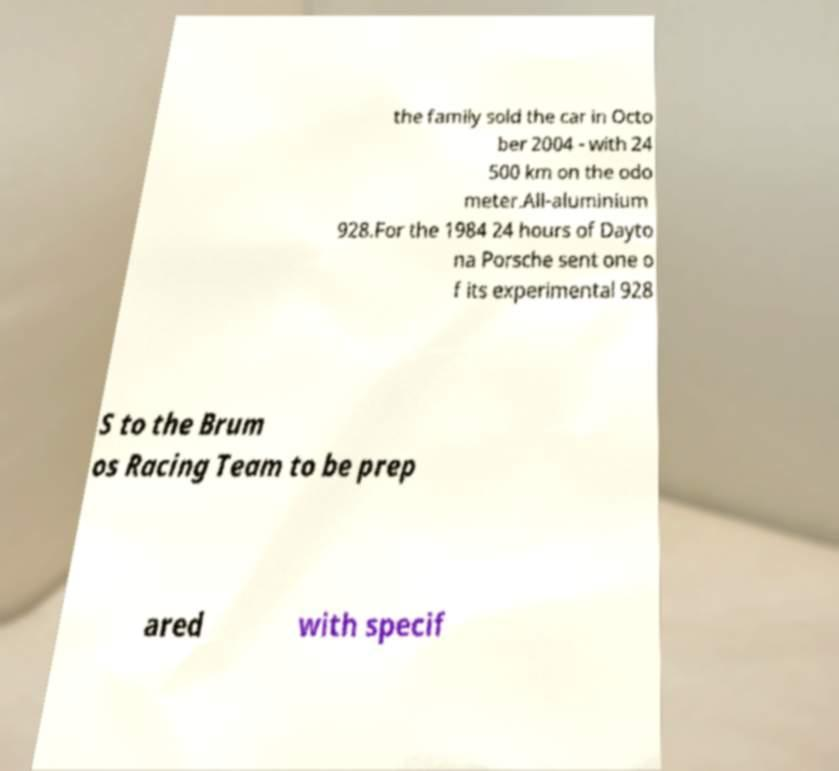Can you accurately transcribe the text from the provided image for me? the family sold the car in Octo ber 2004 - with 24 500 km on the odo meter.All-aluminium 928.For the 1984 24 hours of Dayto na Porsche sent one o f its experimental 928 S to the Brum os Racing Team to be prep ared with specif 